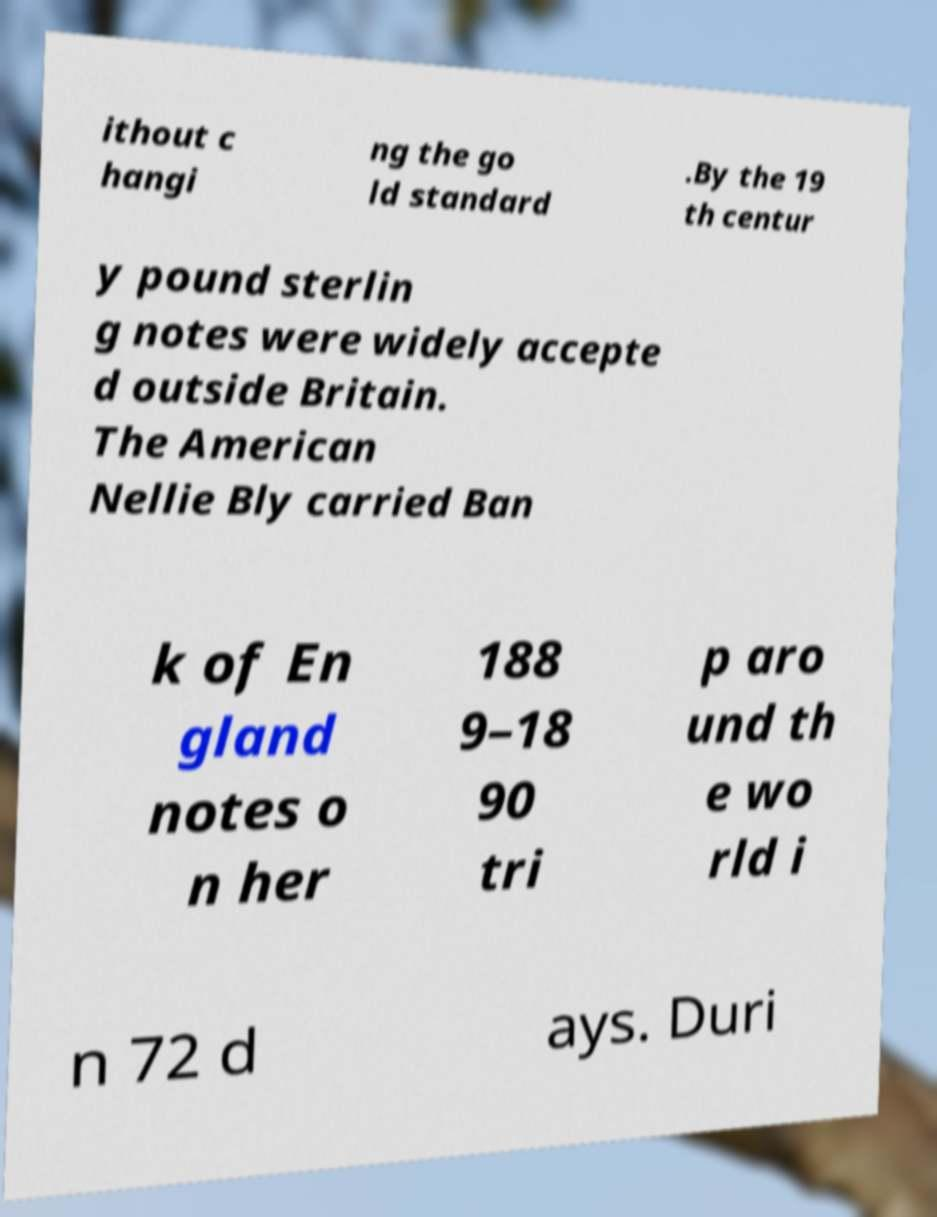Can you accurately transcribe the text from the provided image for me? ithout c hangi ng the go ld standard .By the 19 th centur y pound sterlin g notes were widely accepte d outside Britain. The American Nellie Bly carried Ban k of En gland notes o n her 188 9–18 90 tri p aro und th e wo rld i n 72 d ays. Duri 